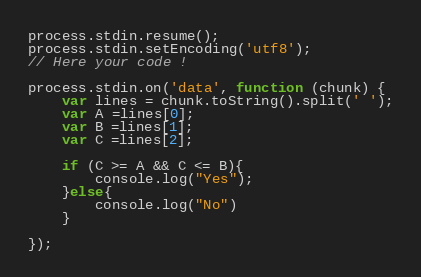Convert code to text. <code><loc_0><loc_0><loc_500><loc_500><_JavaScript_>process.stdin.resume();
process.stdin.setEncoding('utf8');
// Here your code !

process.stdin.on('data', function (chunk) {
    var lines = chunk.toString().split(' ');
    var A =lines[0];
    var B =lines[1];
    var C =lines[2];
    
    if (C >= A && C <= B){
        console.log("Yes");
    }else{
        console.log("No")
    }
    
});

</code> 